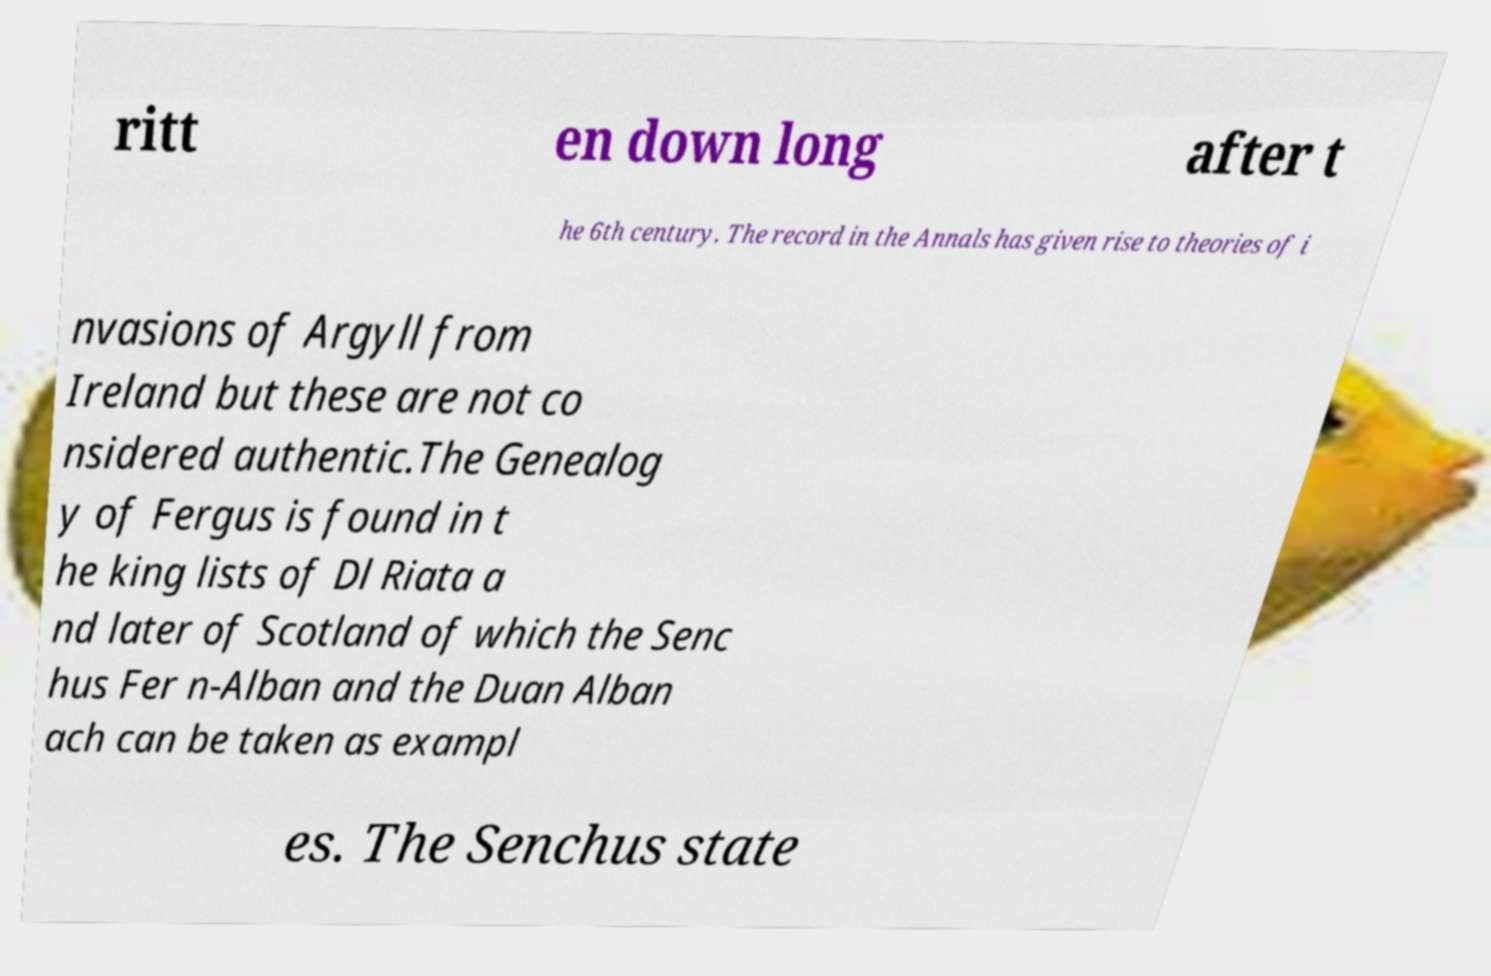Can you read and provide the text displayed in the image?This photo seems to have some interesting text. Can you extract and type it out for me? ritt en down long after t he 6th century. The record in the Annals has given rise to theories of i nvasions of Argyll from Ireland but these are not co nsidered authentic.The Genealog y of Fergus is found in t he king lists of Dl Riata a nd later of Scotland of which the Senc hus Fer n-Alban and the Duan Alban ach can be taken as exampl es. The Senchus state 